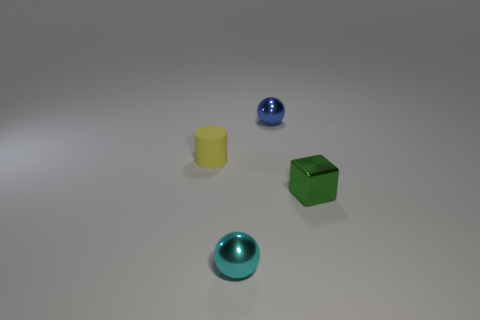Subtract all red balls. Subtract all brown cubes. How many balls are left? 2 Subtract all cyan cubes. How many blue balls are left? 1 Subtract all shiny objects. Subtract all small blue metallic objects. How many objects are left? 0 Add 2 tiny cyan shiny spheres. How many tiny cyan shiny spheres are left? 3 Add 1 tiny cyan metallic spheres. How many tiny cyan metallic spheres exist? 2 Add 2 blue shiny balls. How many objects exist? 6 Subtract all blue spheres. How many spheres are left? 1 Subtract 0 purple cubes. How many objects are left? 4 Subtract all cubes. How many objects are left? 3 